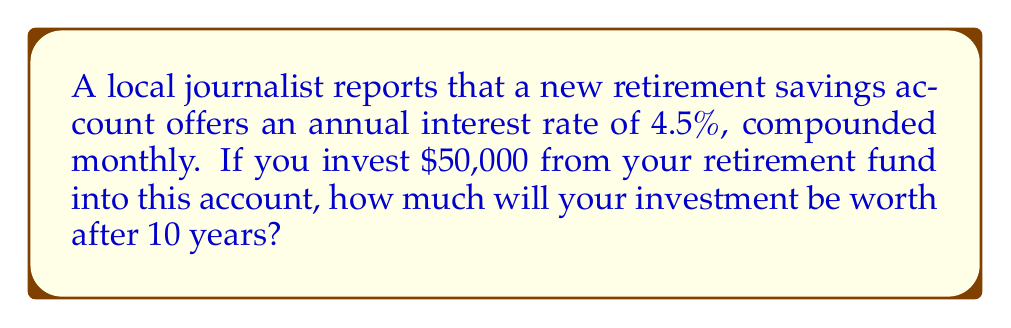Can you solve this math problem? To solve this problem, we'll use the compound interest formula:

$$A = P(1 + \frac{r}{n})^{nt}$$

Where:
$A$ = final amount
$P$ = principal (initial investment)
$r$ = annual interest rate (as a decimal)
$n$ = number of times interest is compounded per year
$t$ = number of years

Given:
$P = \$50,000$
$r = 4.5\% = 0.045$
$n = 12$ (compounded monthly)
$t = 10$ years

Let's substitute these values into the formula:

$$A = 50000(1 + \frac{0.045}{12})^{12 \cdot 10}$$

$$A = 50000(1 + 0.00375)^{120}$$

$$A = 50000(1.00375)^{120}$$

Using a calculator:

$$A = 50000 \cdot 1.5672$$

$$A = 78,360.00$$

Therefore, after 10 years, your investment will be worth $78,360.00.
Answer: $78,360.00 